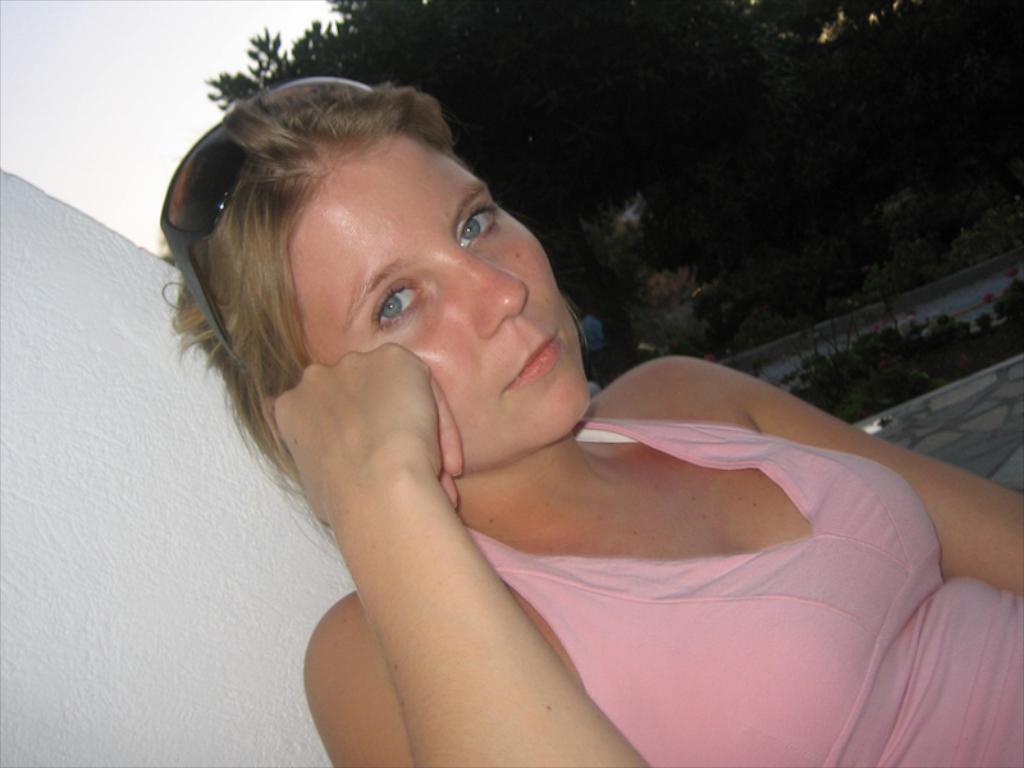Can you describe this image briefly? In this picture we can see a woman in the front, in the background there are some trees and plants, we can see the sky at the left top of the picture. 